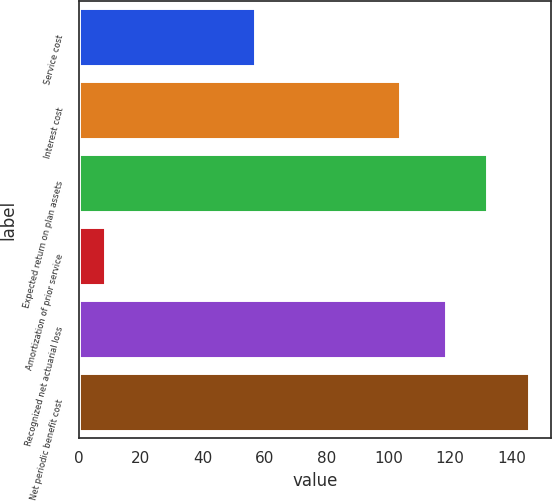<chart> <loc_0><loc_0><loc_500><loc_500><bar_chart><fcel>Service cost<fcel>Interest cost<fcel>Expected return on plan assets<fcel>Amortization of prior service<fcel>Recognized net actuarial loss<fcel>Net periodic benefit cost<nl><fcel>57.1<fcel>103.8<fcel>131.96<fcel>8.7<fcel>118.5<fcel>145.42<nl></chart> 